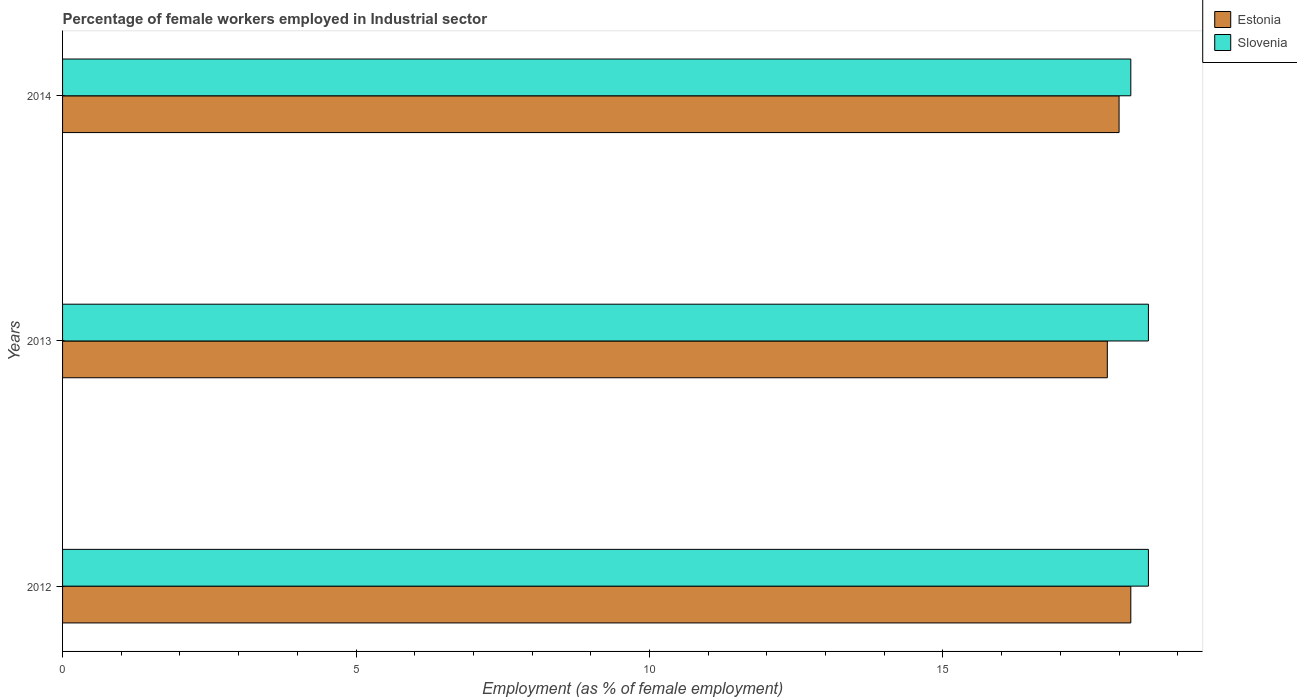Are the number of bars per tick equal to the number of legend labels?
Provide a short and direct response. Yes. Are the number of bars on each tick of the Y-axis equal?
Provide a succinct answer. Yes. What is the label of the 1st group of bars from the top?
Ensure brevity in your answer.  2014. What is the percentage of females employed in Industrial sector in Slovenia in 2012?
Your response must be concise. 18.5. Across all years, what is the maximum percentage of females employed in Industrial sector in Estonia?
Your answer should be very brief. 18.2. Across all years, what is the minimum percentage of females employed in Industrial sector in Estonia?
Ensure brevity in your answer.  17.8. In which year was the percentage of females employed in Industrial sector in Slovenia minimum?
Provide a succinct answer. 2014. What is the total percentage of females employed in Industrial sector in Slovenia in the graph?
Offer a very short reply. 55.2. What is the difference between the percentage of females employed in Industrial sector in Estonia in 2013 and that in 2014?
Provide a short and direct response. -0.2. What is the average percentage of females employed in Industrial sector in Estonia per year?
Your response must be concise. 18. In the year 2012, what is the difference between the percentage of females employed in Industrial sector in Slovenia and percentage of females employed in Industrial sector in Estonia?
Your response must be concise. 0.3. What is the ratio of the percentage of females employed in Industrial sector in Slovenia in 2012 to that in 2014?
Offer a very short reply. 1.02. Is the difference between the percentage of females employed in Industrial sector in Slovenia in 2013 and 2014 greater than the difference between the percentage of females employed in Industrial sector in Estonia in 2013 and 2014?
Provide a short and direct response. Yes. What is the difference between the highest and the lowest percentage of females employed in Industrial sector in Estonia?
Your answer should be compact. 0.4. Is the sum of the percentage of females employed in Industrial sector in Estonia in 2013 and 2014 greater than the maximum percentage of females employed in Industrial sector in Slovenia across all years?
Keep it short and to the point. Yes. What does the 1st bar from the top in 2012 represents?
Make the answer very short. Slovenia. What does the 2nd bar from the bottom in 2012 represents?
Offer a terse response. Slovenia. Are all the bars in the graph horizontal?
Provide a short and direct response. Yes. Does the graph contain grids?
Provide a short and direct response. No. Where does the legend appear in the graph?
Give a very brief answer. Top right. What is the title of the graph?
Offer a terse response. Percentage of female workers employed in Industrial sector. What is the label or title of the X-axis?
Offer a very short reply. Employment (as % of female employment). What is the label or title of the Y-axis?
Your answer should be compact. Years. What is the Employment (as % of female employment) of Estonia in 2012?
Provide a short and direct response. 18.2. What is the Employment (as % of female employment) in Estonia in 2013?
Your answer should be very brief. 17.8. What is the Employment (as % of female employment) of Slovenia in 2013?
Give a very brief answer. 18.5. What is the Employment (as % of female employment) in Slovenia in 2014?
Provide a succinct answer. 18.2. Across all years, what is the maximum Employment (as % of female employment) of Estonia?
Your answer should be very brief. 18.2. Across all years, what is the minimum Employment (as % of female employment) of Estonia?
Offer a terse response. 17.8. Across all years, what is the minimum Employment (as % of female employment) in Slovenia?
Ensure brevity in your answer.  18.2. What is the total Employment (as % of female employment) in Estonia in the graph?
Ensure brevity in your answer.  54. What is the total Employment (as % of female employment) in Slovenia in the graph?
Provide a short and direct response. 55.2. What is the difference between the Employment (as % of female employment) in Estonia in 2012 and that in 2013?
Keep it short and to the point. 0.4. What is the difference between the Employment (as % of female employment) in Slovenia in 2012 and that in 2014?
Give a very brief answer. 0.3. What is the difference between the Employment (as % of female employment) of Estonia in 2013 and that in 2014?
Offer a very short reply. -0.2. What is the difference between the Employment (as % of female employment) in Estonia in 2013 and the Employment (as % of female employment) in Slovenia in 2014?
Your response must be concise. -0.4. What is the average Employment (as % of female employment) in Estonia per year?
Make the answer very short. 18. What is the average Employment (as % of female employment) of Slovenia per year?
Provide a succinct answer. 18.4. In the year 2012, what is the difference between the Employment (as % of female employment) of Estonia and Employment (as % of female employment) of Slovenia?
Offer a terse response. -0.3. In the year 2013, what is the difference between the Employment (as % of female employment) in Estonia and Employment (as % of female employment) in Slovenia?
Your answer should be very brief. -0.7. What is the ratio of the Employment (as % of female employment) of Estonia in 2012 to that in 2013?
Provide a short and direct response. 1.02. What is the ratio of the Employment (as % of female employment) of Slovenia in 2012 to that in 2013?
Your response must be concise. 1. What is the ratio of the Employment (as % of female employment) of Estonia in 2012 to that in 2014?
Offer a very short reply. 1.01. What is the ratio of the Employment (as % of female employment) of Slovenia in 2012 to that in 2014?
Your answer should be very brief. 1.02. What is the ratio of the Employment (as % of female employment) in Estonia in 2013 to that in 2014?
Make the answer very short. 0.99. What is the ratio of the Employment (as % of female employment) of Slovenia in 2013 to that in 2014?
Your answer should be compact. 1.02. What is the difference between the highest and the lowest Employment (as % of female employment) of Estonia?
Keep it short and to the point. 0.4. 